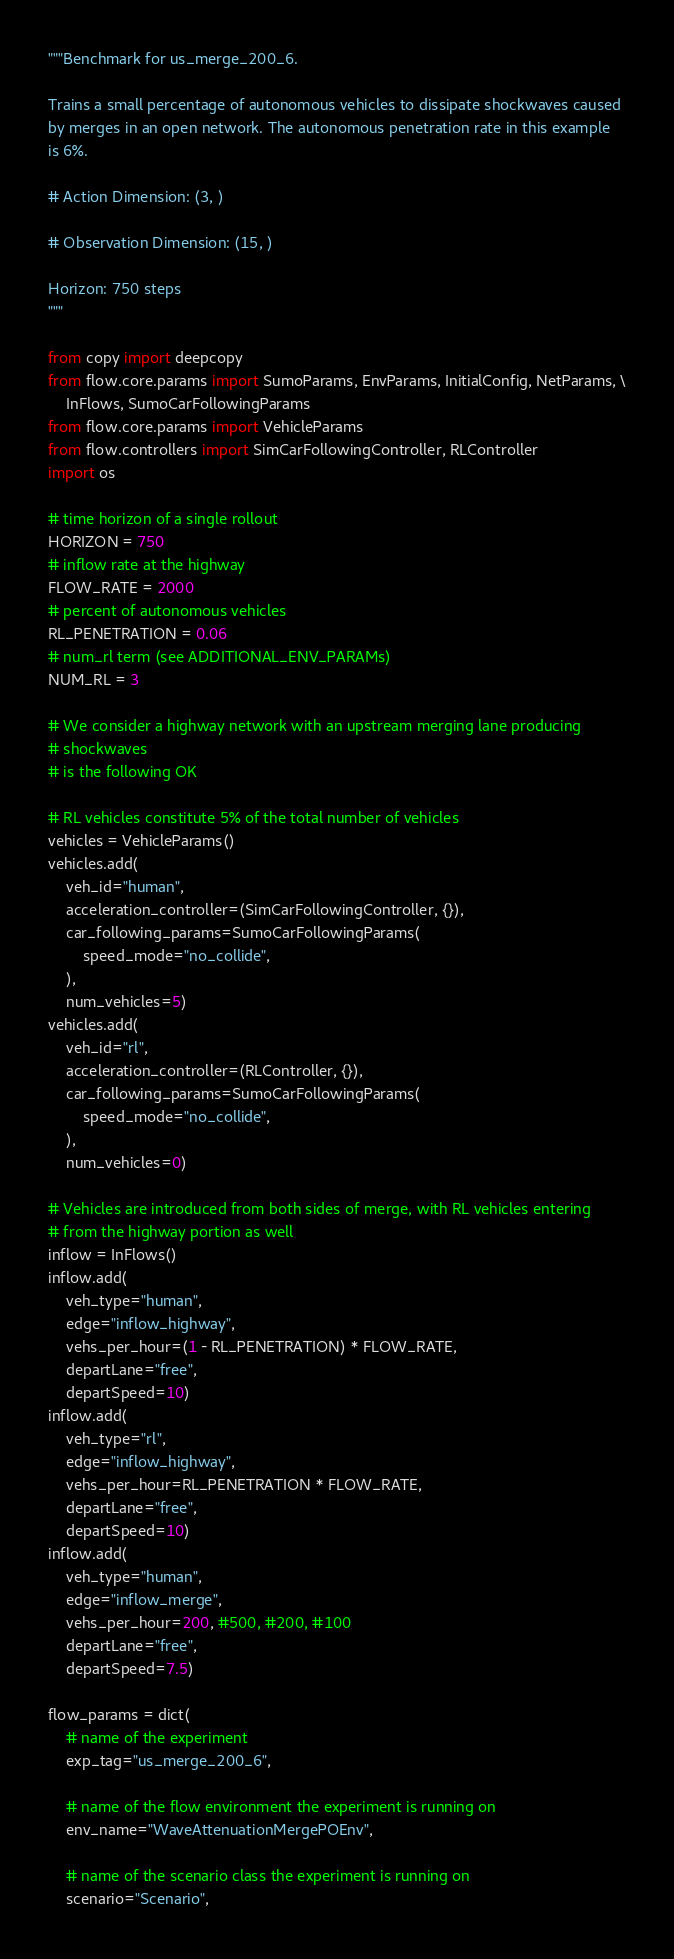<code> <loc_0><loc_0><loc_500><loc_500><_Python_>"""Benchmark for us_merge_200_6.

Trains a small percentage of autonomous vehicles to dissipate shockwaves caused
by merges in an open network. The autonomous penetration rate in this example
is 6%.

# Action Dimension: (3, )

# Observation Dimension: (15, )

Horizon: 750 steps
"""

from copy import deepcopy
from flow.core.params import SumoParams, EnvParams, InitialConfig, NetParams, \
    InFlows, SumoCarFollowingParams
from flow.core.params import VehicleParams
from flow.controllers import SimCarFollowingController, RLController
import os

# time horizon of a single rollout
HORIZON = 750
# inflow rate at the highway
FLOW_RATE = 2000
# percent of autonomous vehicles
RL_PENETRATION = 0.06
# num_rl term (see ADDITIONAL_ENV_PARAMs)
NUM_RL = 3

# We consider a highway network with an upstream merging lane producing
# shockwaves
# is the following OK

# RL vehicles constitute 5% of the total number of vehicles
vehicles = VehicleParams()
vehicles.add(
    veh_id="human",
    acceleration_controller=(SimCarFollowingController, {}),
    car_following_params=SumoCarFollowingParams(
        speed_mode="no_collide",
    ),
    num_vehicles=5)
vehicles.add(
    veh_id="rl",
    acceleration_controller=(RLController, {}),
    car_following_params=SumoCarFollowingParams(
        speed_mode="no_collide",
    ),
    num_vehicles=0)

# Vehicles are introduced from both sides of merge, with RL vehicles entering
# from the highway portion as well
inflow = InFlows()
inflow.add(
    veh_type="human",
    edge="inflow_highway",
    vehs_per_hour=(1 - RL_PENETRATION) * FLOW_RATE,
    departLane="free",
    departSpeed=10)
inflow.add(
    veh_type="rl",
    edge="inflow_highway",
    vehs_per_hour=RL_PENETRATION * FLOW_RATE,
    departLane="free",
    departSpeed=10)
inflow.add(
    veh_type="human",
    edge="inflow_merge",
    vehs_per_hour=200, #500, #200, #100
    departLane="free",
    departSpeed=7.5)

flow_params = dict(
    # name of the experiment
    exp_tag="us_merge_200_6",

    # name of the flow environment the experiment is running on
    env_name="WaveAttenuationMergePOEnv",

    # name of the scenario class the experiment is running on
    scenario="Scenario",
</code> 